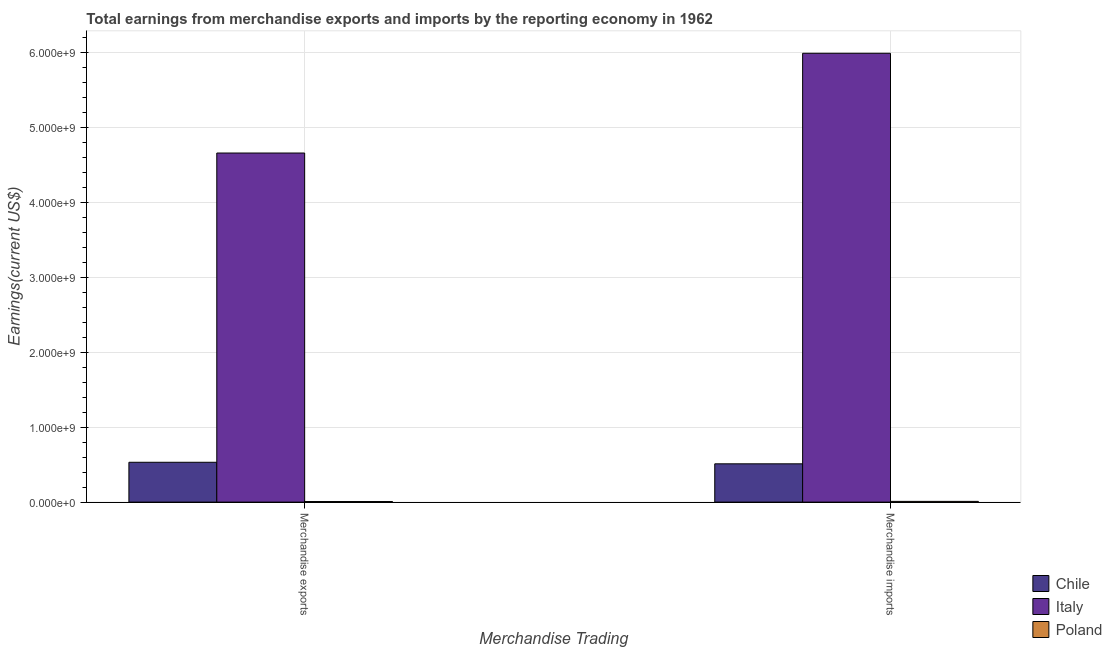How many different coloured bars are there?
Give a very brief answer. 3. Are the number of bars on each tick of the X-axis equal?
Offer a terse response. Yes. How many bars are there on the 1st tick from the right?
Make the answer very short. 3. What is the earnings from merchandise imports in Poland?
Keep it short and to the point. 9.90e+06. Across all countries, what is the maximum earnings from merchandise imports?
Offer a terse response. 5.99e+09. Across all countries, what is the minimum earnings from merchandise imports?
Offer a very short reply. 9.90e+06. What is the total earnings from merchandise imports in the graph?
Your answer should be compact. 6.51e+09. What is the difference between the earnings from merchandise exports in Poland and that in Chile?
Provide a succinct answer. -5.24e+08. What is the difference between the earnings from merchandise exports in Poland and the earnings from merchandise imports in Italy?
Give a very brief answer. -5.98e+09. What is the average earnings from merchandise imports per country?
Keep it short and to the point. 2.17e+09. What is the difference between the earnings from merchandise imports and earnings from merchandise exports in Chile?
Your answer should be compact. -2.06e+07. What is the ratio of the earnings from merchandise exports in Poland to that in Chile?
Ensure brevity in your answer.  0.01. What does the 2nd bar from the left in Merchandise exports represents?
Your response must be concise. Italy. How many bars are there?
Give a very brief answer. 6. Are all the bars in the graph horizontal?
Your answer should be compact. No. Does the graph contain any zero values?
Keep it short and to the point. No. Where does the legend appear in the graph?
Provide a short and direct response. Bottom right. How many legend labels are there?
Ensure brevity in your answer.  3. How are the legend labels stacked?
Keep it short and to the point. Vertical. What is the title of the graph?
Provide a short and direct response. Total earnings from merchandise exports and imports by the reporting economy in 1962. Does "Myanmar" appear as one of the legend labels in the graph?
Offer a terse response. No. What is the label or title of the X-axis?
Provide a succinct answer. Merchandise Trading. What is the label or title of the Y-axis?
Your answer should be compact. Earnings(current US$). What is the Earnings(current US$) of Chile in Merchandise exports?
Your response must be concise. 5.32e+08. What is the Earnings(current US$) in Italy in Merchandise exports?
Give a very brief answer. 4.66e+09. What is the Earnings(current US$) of Poland in Merchandise exports?
Your answer should be very brief. 7.80e+06. What is the Earnings(current US$) of Chile in Merchandise imports?
Offer a terse response. 5.11e+08. What is the Earnings(current US$) in Italy in Merchandise imports?
Your answer should be very brief. 5.99e+09. What is the Earnings(current US$) of Poland in Merchandise imports?
Your answer should be compact. 9.90e+06. Across all Merchandise Trading, what is the maximum Earnings(current US$) in Chile?
Make the answer very short. 5.32e+08. Across all Merchandise Trading, what is the maximum Earnings(current US$) in Italy?
Your answer should be compact. 5.99e+09. Across all Merchandise Trading, what is the maximum Earnings(current US$) of Poland?
Your answer should be compact. 9.90e+06. Across all Merchandise Trading, what is the minimum Earnings(current US$) in Chile?
Offer a very short reply. 5.11e+08. Across all Merchandise Trading, what is the minimum Earnings(current US$) of Italy?
Ensure brevity in your answer.  4.66e+09. Across all Merchandise Trading, what is the minimum Earnings(current US$) of Poland?
Keep it short and to the point. 7.80e+06. What is the total Earnings(current US$) in Chile in the graph?
Your answer should be compact. 1.04e+09. What is the total Earnings(current US$) in Italy in the graph?
Make the answer very short. 1.07e+1. What is the total Earnings(current US$) in Poland in the graph?
Give a very brief answer. 1.77e+07. What is the difference between the Earnings(current US$) of Chile in Merchandise exports and that in Merchandise imports?
Offer a very short reply. 2.06e+07. What is the difference between the Earnings(current US$) of Italy in Merchandise exports and that in Merchandise imports?
Your response must be concise. -1.33e+09. What is the difference between the Earnings(current US$) of Poland in Merchandise exports and that in Merchandise imports?
Offer a very short reply. -2.10e+06. What is the difference between the Earnings(current US$) of Chile in Merchandise exports and the Earnings(current US$) of Italy in Merchandise imports?
Offer a very short reply. -5.46e+09. What is the difference between the Earnings(current US$) of Chile in Merchandise exports and the Earnings(current US$) of Poland in Merchandise imports?
Your answer should be compact. 5.22e+08. What is the difference between the Earnings(current US$) of Italy in Merchandise exports and the Earnings(current US$) of Poland in Merchandise imports?
Your answer should be very brief. 4.65e+09. What is the average Earnings(current US$) of Chile per Merchandise Trading?
Make the answer very short. 5.22e+08. What is the average Earnings(current US$) of Italy per Merchandise Trading?
Keep it short and to the point. 5.33e+09. What is the average Earnings(current US$) of Poland per Merchandise Trading?
Provide a short and direct response. 8.85e+06. What is the difference between the Earnings(current US$) of Chile and Earnings(current US$) of Italy in Merchandise exports?
Offer a terse response. -4.13e+09. What is the difference between the Earnings(current US$) in Chile and Earnings(current US$) in Poland in Merchandise exports?
Provide a succinct answer. 5.24e+08. What is the difference between the Earnings(current US$) in Italy and Earnings(current US$) in Poland in Merchandise exports?
Provide a succinct answer. 4.65e+09. What is the difference between the Earnings(current US$) of Chile and Earnings(current US$) of Italy in Merchandise imports?
Provide a short and direct response. -5.48e+09. What is the difference between the Earnings(current US$) of Chile and Earnings(current US$) of Poland in Merchandise imports?
Give a very brief answer. 5.01e+08. What is the difference between the Earnings(current US$) of Italy and Earnings(current US$) of Poland in Merchandise imports?
Offer a terse response. 5.98e+09. What is the ratio of the Earnings(current US$) in Chile in Merchandise exports to that in Merchandise imports?
Your answer should be compact. 1.04. What is the ratio of the Earnings(current US$) of Poland in Merchandise exports to that in Merchandise imports?
Offer a very short reply. 0.79. What is the difference between the highest and the second highest Earnings(current US$) of Chile?
Keep it short and to the point. 2.06e+07. What is the difference between the highest and the second highest Earnings(current US$) of Italy?
Provide a succinct answer. 1.33e+09. What is the difference between the highest and the second highest Earnings(current US$) of Poland?
Make the answer very short. 2.10e+06. What is the difference between the highest and the lowest Earnings(current US$) in Chile?
Provide a succinct answer. 2.06e+07. What is the difference between the highest and the lowest Earnings(current US$) in Italy?
Provide a succinct answer. 1.33e+09. What is the difference between the highest and the lowest Earnings(current US$) of Poland?
Provide a succinct answer. 2.10e+06. 